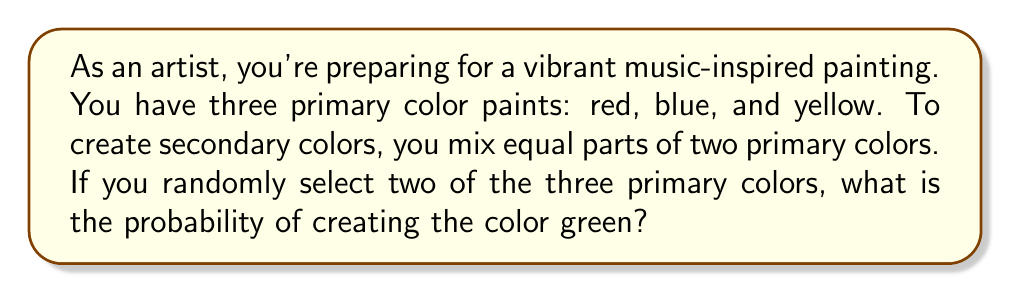Show me your answer to this math problem. Let's approach this step-by-step:

1) First, recall that green is created by mixing blue and yellow.

2) We need to calculate the probability of selecting blue and yellow out of the three primary colors.

3) To do this, we can use the concept of combinations. We're selecting 2 colors out of 3, where the order doesn't matter.

4) The total number of ways to select 2 colors out of 3 is given by the combination formula:

   $$\binom{3}{2} = \frac{3!}{2!(3-2)!} = \frac{3 \cdot 2 \cdot 1}{(2 \cdot 1)(1)} = 3$$

5) Out of these 3 possible combinations, only 1 combination (blue and yellow) creates green.

6) Therefore, the probability is:

   $$P(\text{green}) = \frac{\text{favorable outcomes}}{\text{total outcomes}} = \frac{1}{3}$$
Answer: $\frac{1}{3}$ 